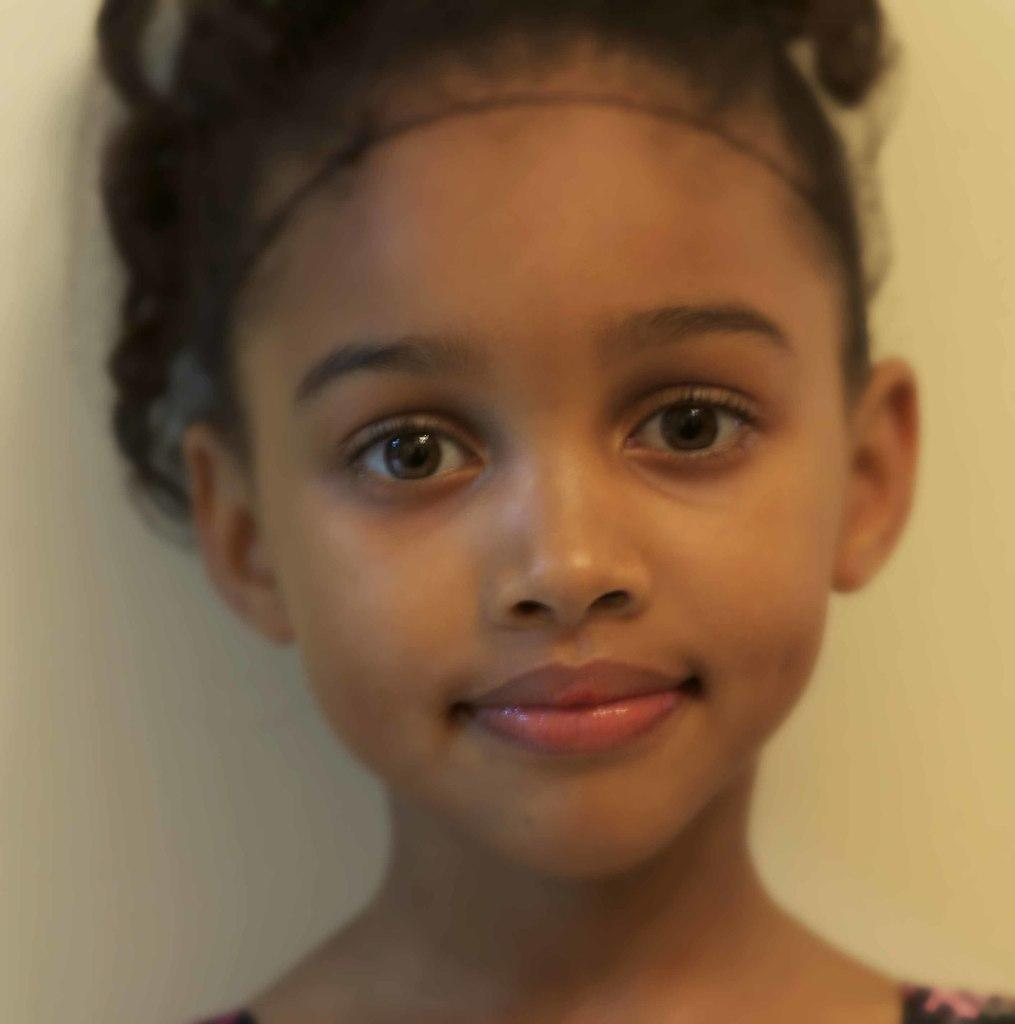Who is the main subject in the picture? There is a girl in the picture. What is the girl doing in the picture? The girl is smiling. What can be seen in the background of the picture? There is a wall in the background of the picture. What type of sand is visible on the girl's stocking in the image? There is no sand or stocking present in the image. Is the girl's grandfather visible in the image? There is no mention of a grandfather or any other person in the image besides the girl. 